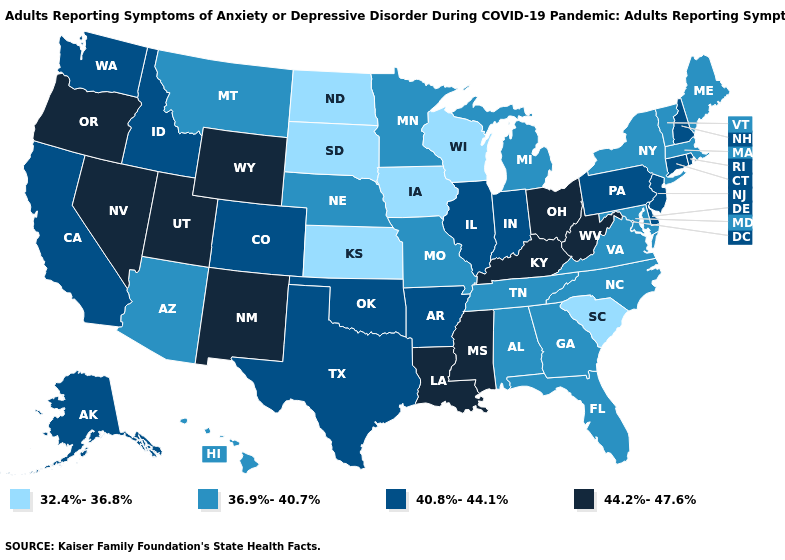What is the lowest value in the West?
Keep it brief. 36.9%-40.7%. Does Montana have the highest value in the West?
Be succinct. No. What is the highest value in the USA?
Keep it brief. 44.2%-47.6%. What is the lowest value in the Northeast?
Keep it brief. 36.9%-40.7%. Name the states that have a value in the range 40.8%-44.1%?
Give a very brief answer. Alaska, Arkansas, California, Colorado, Connecticut, Delaware, Idaho, Illinois, Indiana, New Hampshire, New Jersey, Oklahoma, Pennsylvania, Rhode Island, Texas, Washington. What is the value of Wyoming?
Give a very brief answer. 44.2%-47.6%. Does Montana have the lowest value in the West?
Keep it brief. Yes. What is the highest value in the Northeast ?
Give a very brief answer. 40.8%-44.1%. Name the states that have a value in the range 32.4%-36.8%?
Quick response, please. Iowa, Kansas, North Dakota, South Carolina, South Dakota, Wisconsin. What is the value of Idaho?
Give a very brief answer. 40.8%-44.1%. Does South Dakota have the highest value in the MidWest?
Answer briefly. No. Does Tennessee have a lower value than Kentucky?
Quick response, please. Yes. Which states have the highest value in the USA?
Short answer required. Kentucky, Louisiana, Mississippi, Nevada, New Mexico, Ohio, Oregon, Utah, West Virginia, Wyoming. Does South Carolina have the lowest value in the USA?
Give a very brief answer. Yes. What is the lowest value in the Northeast?
Answer briefly. 36.9%-40.7%. 